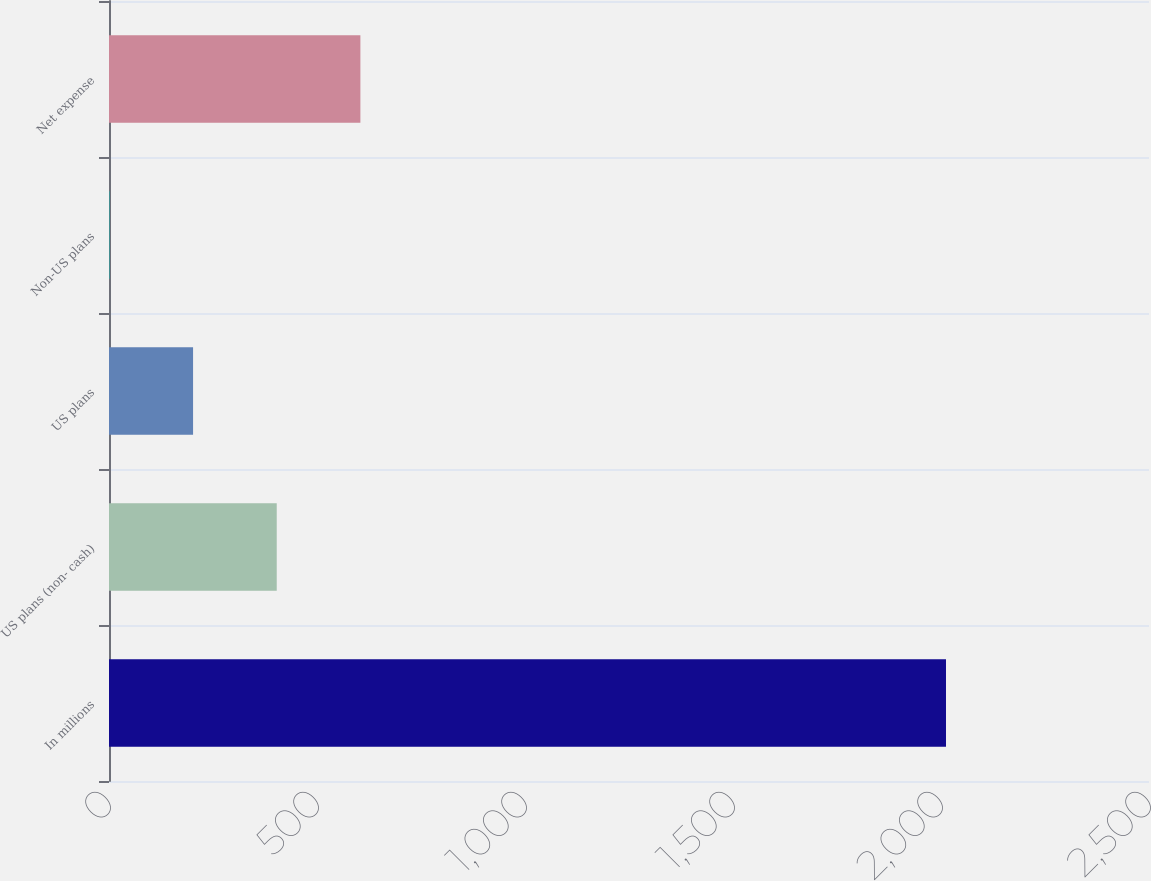Convert chart to OTSL. <chart><loc_0><loc_0><loc_500><loc_500><bar_chart><fcel>In millions<fcel>US plans (non- cash)<fcel>US plans<fcel>Non-US plans<fcel>Net expense<nl><fcel>2012<fcel>403.2<fcel>202.1<fcel>1<fcel>604.3<nl></chart> 